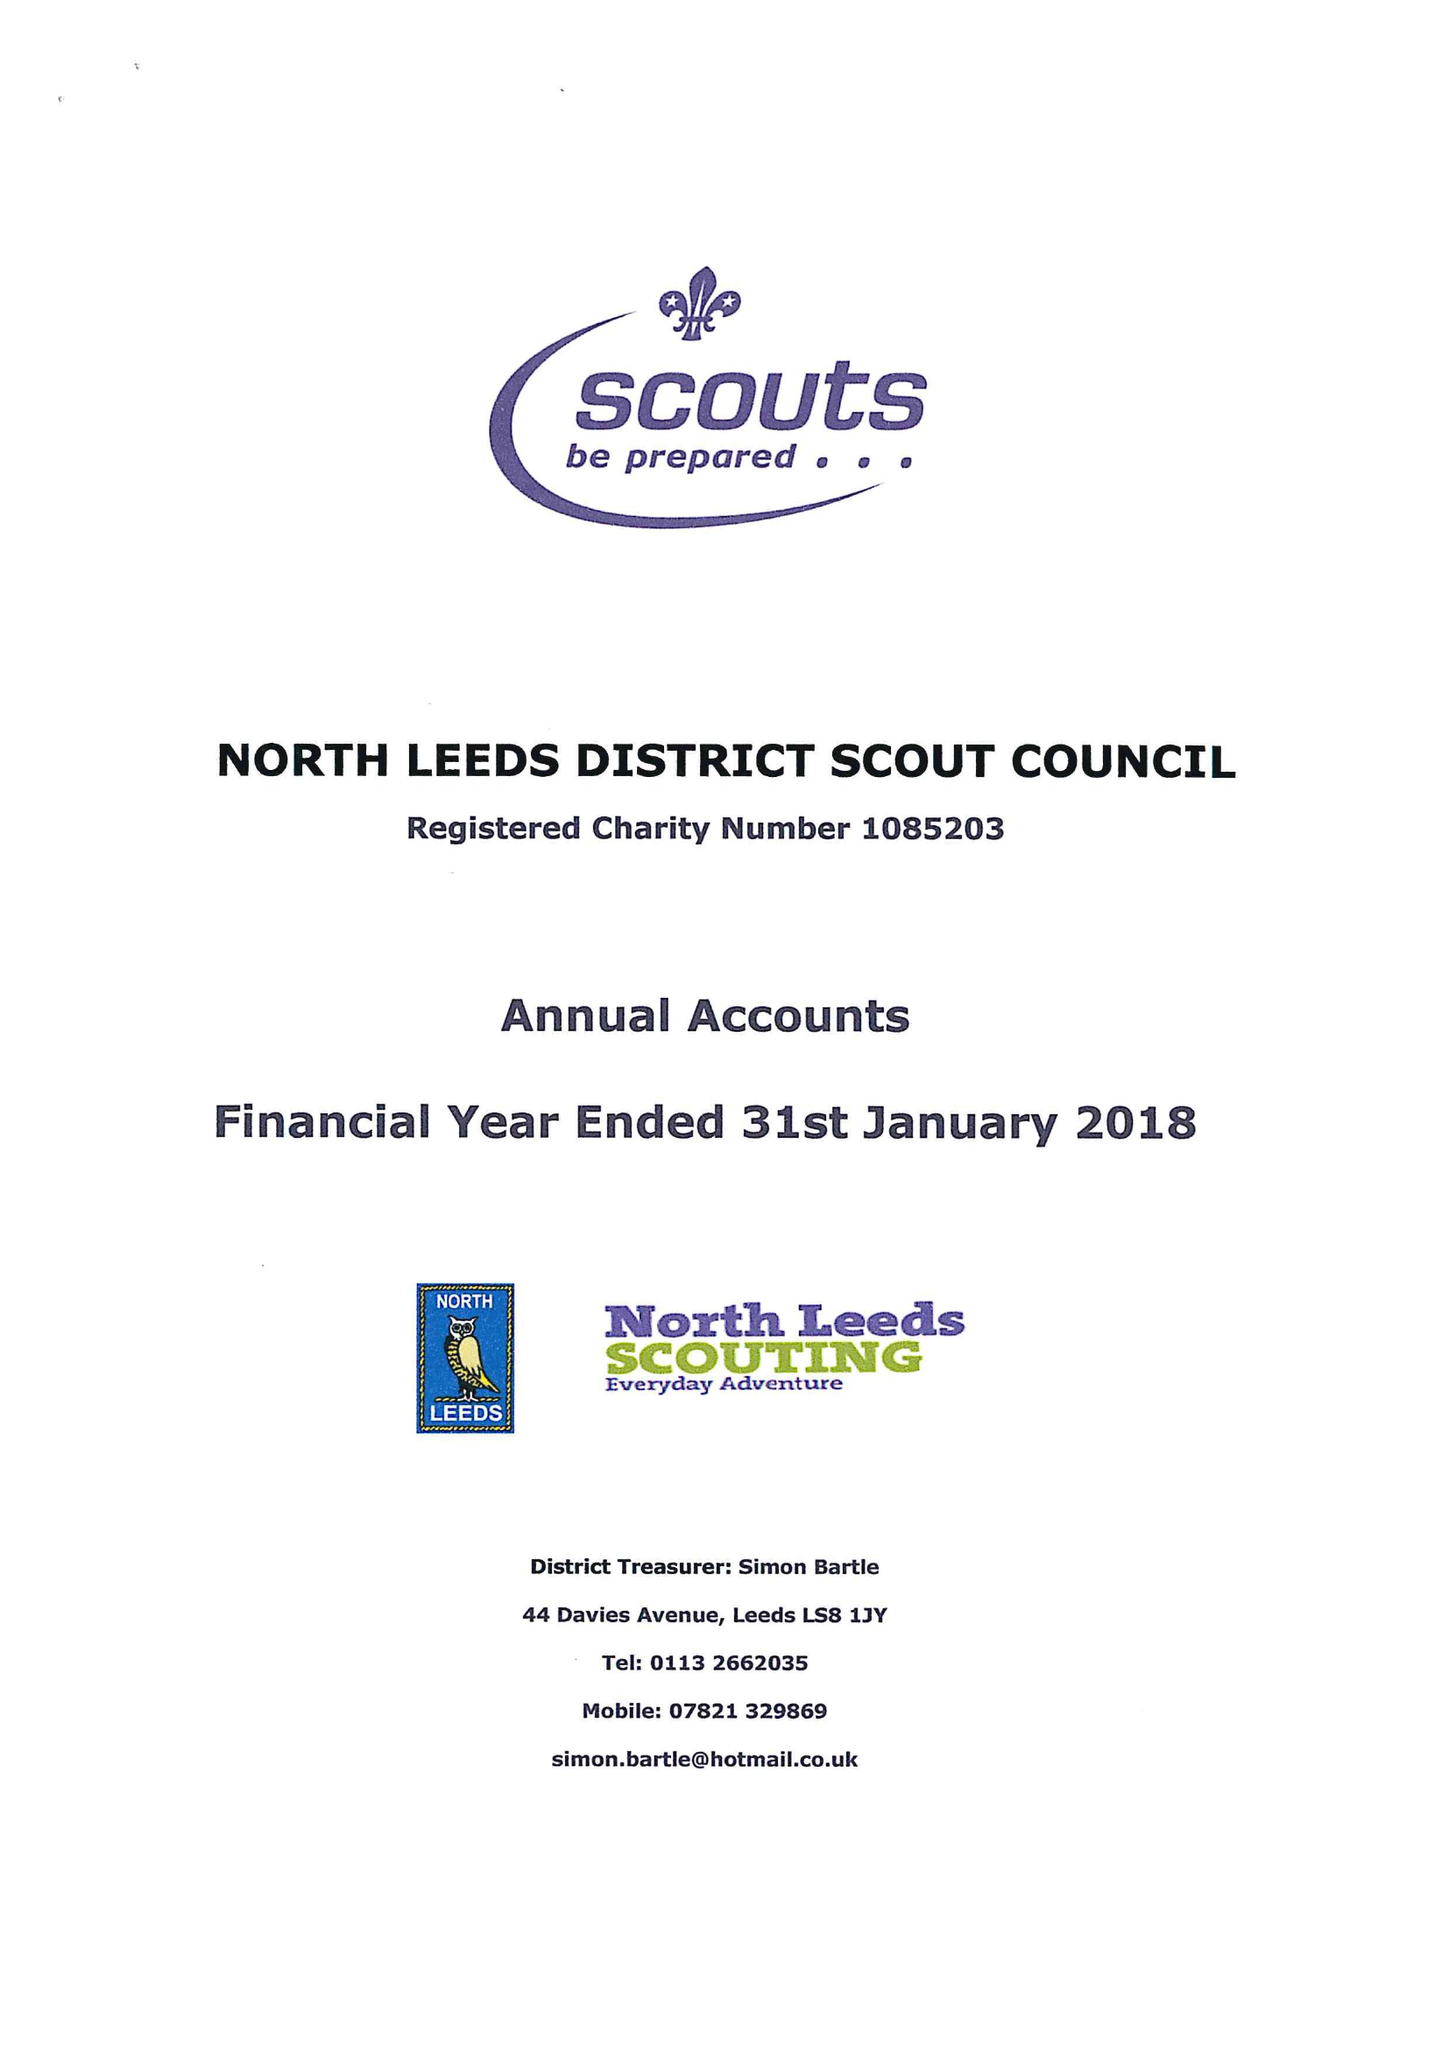What is the value for the charity_number?
Answer the question using a single word or phrase. 1085203 